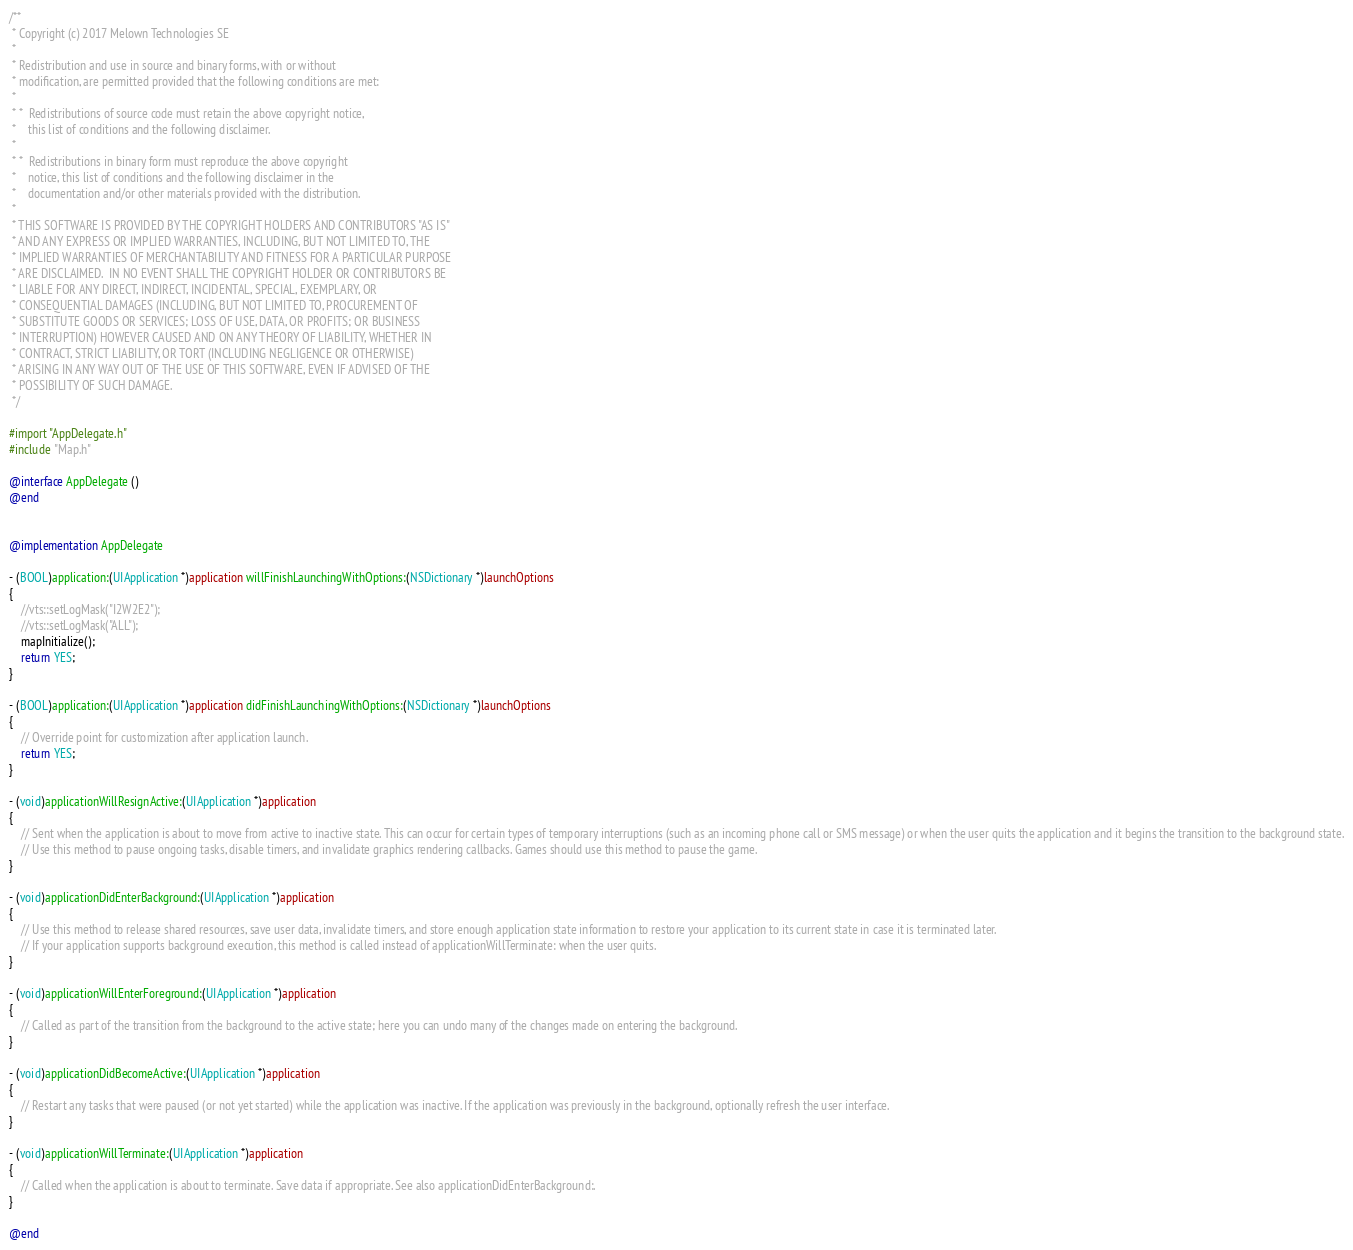<code> <loc_0><loc_0><loc_500><loc_500><_ObjectiveC_>/**
 * Copyright (c) 2017 Melown Technologies SE
 *
 * Redistribution and use in source and binary forms, with or without
 * modification, are permitted provided that the following conditions are met:
 *
 * *  Redistributions of source code must retain the above copyright notice,
 *    this list of conditions and the following disclaimer.
 *
 * *  Redistributions in binary form must reproduce the above copyright
 *    notice, this list of conditions and the following disclaimer in the
 *    documentation and/or other materials provided with the distribution.
 *
 * THIS SOFTWARE IS PROVIDED BY THE COPYRIGHT HOLDERS AND CONTRIBUTORS "AS IS"
 * AND ANY EXPRESS OR IMPLIED WARRANTIES, INCLUDING, BUT NOT LIMITED TO, THE
 * IMPLIED WARRANTIES OF MERCHANTABILITY AND FITNESS FOR A PARTICULAR PURPOSE
 * ARE DISCLAIMED.  IN NO EVENT SHALL THE COPYRIGHT HOLDER OR CONTRIBUTORS BE
 * LIABLE FOR ANY DIRECT, INDIRECT, INCIDENTAL, SPECIAL, EXEMPLARY, OR
 * CONSEQUENTIAL DAMAGES (INCLUDING, BUT NOT LIMITED TO, PROCUREMENT OF
 * SUBSTITUTE GOODS OR SERVICES; LOSS OF USE, DATA, OR PROFITS; OR BUSINESS
 * INTERRUPTION) HOWEVER CAUSED AND ON ANY THEORY OF LIABILITY, WHETHER IN
 * CONTRACT, STRICT LIABILITY, OR TORT (INCLUDING NEGLIGENCE OR OTHERWISE)
 * ARISING IN ANY WAY OUT OF THE USE OF THIS SOFTWARE, EVEN IF ADVISED OF THE
 * POSSIBILITY OF SUCH DAMAGE.
 */

#import "AppDelegate.h"
#include "Map.h"

@interface AppDelegate ()
@end


@implementation AppDelegate

- (BOOL)application:(UIApplication *)application willFinishLaunchingWithOptions:(NSDictionary *)launchOptions
{
    //vts::setLogMask("I2W2E2");
    //vts::setLogMask("ALL");
    mapInitialize();
    return YES;
}

- (BOOL)application:(UIApplication *)application didFinishLaunchingWithOptions:(NSDictionary *)launchOptions
{
    // Override point for customization after application launch.
    return YES;
}

- (void)applicationWillResignActive:(UIApplication *)application
{
    // Sent when the application is about to move from active to inactive state. This can occur for certain types of temporary interruptions (such as an incoming phone call or SMS message) or when the user quits the application and it begins the transition to the background state.
    // Use this method to pause ongoing tasks, disable timers, and invalidate graphics rendering callbacks. Games should use this method to pause the game.
}

- (void)applicationDidEnterBackground:(UIApplication *)application
{
    // Use this method to release shared resources, save user data, invalidate timers, and store enough application state information to restore your application to its current state in case it is terminated later.
    // If your application supports background execution, this method is called instead of applicationWillTerminate: when the user quits.
}

- (void)applicationWillEnterForeground:(UIApplication *)application
{
    // Called as part of the transition from the background to the active state; here you can undo many of the changes made on entering the background.
}

- (void)applicationDidBecomeActive:(UIApplication *)application
{
    // Restart any tasks that were paused (or not yet started) while the application was inactive. If the application was previously in the background, optionally refresh the user interface.
}

- (void)applicationWillTerminate:(UIApplication *)application
{
    // Called when the application is about to terminate. Save data if appropriate. See also applicationDidEnterBackground:.
}

@end

</code> 